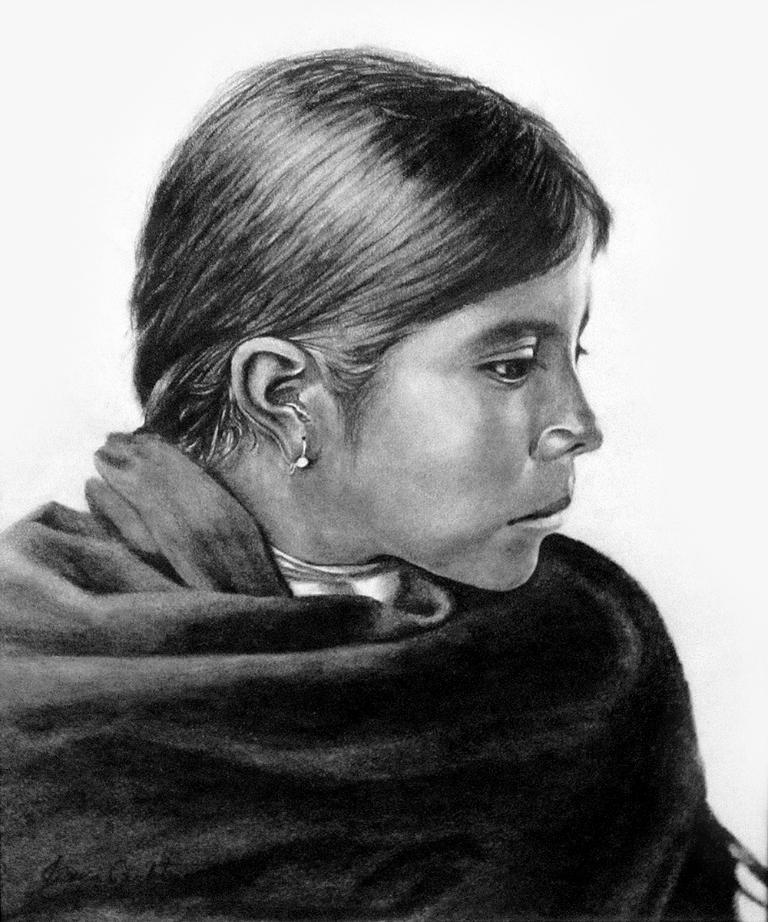What is depicted in the image? There is a painting of a woman in the image. Can you describe the background of the painting? The background of the painting is white. What impulse caused the woman to be painted in the image? There is no information about the impulse or reason for the painting in the image. 